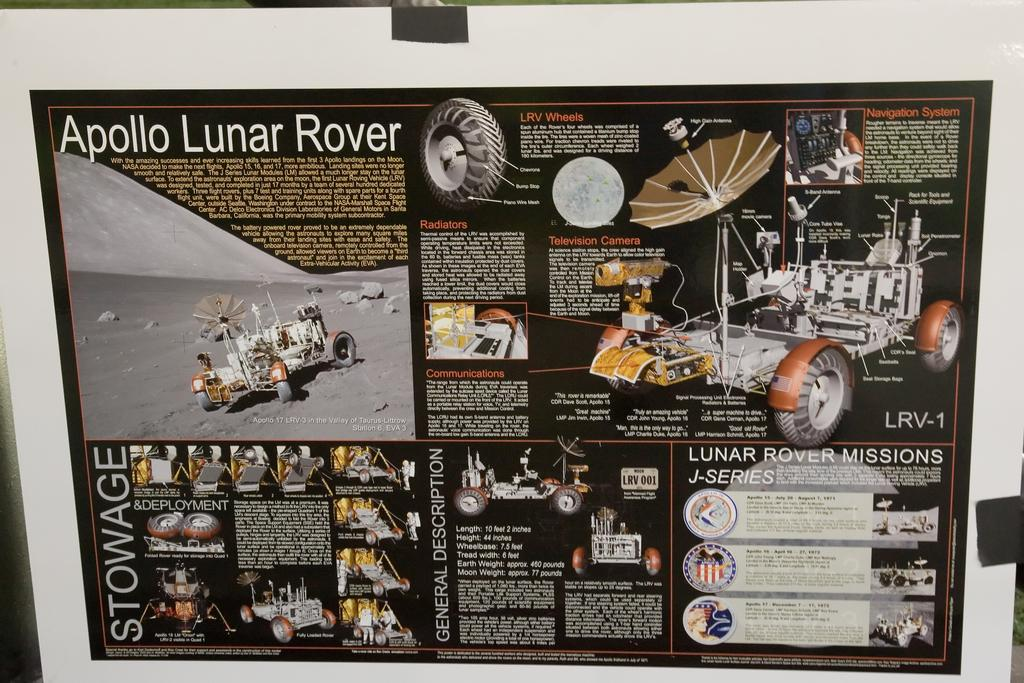<image>
Render a clear and concise summary of the photo. A Apollo Lunar Rover poster with a picture of the rover and a detail description of the rover. 